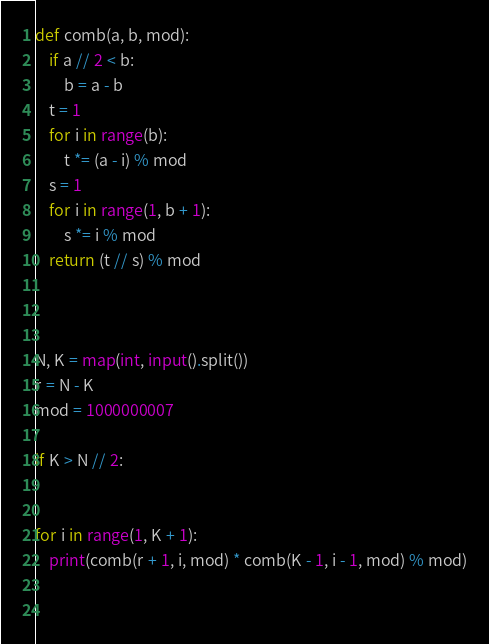Convert code to text. <code><loc_0><loc_0><loc_500><loc_500><_Python_>def comb(a, b, mod):
    if a // 2 < b:
        b = a - b
    t = 1
    for i in range(b):
        t *= (a - i) % mod
    s = 1
    for i in range(1, b + 1):
        s *= i % mod
    return (t // s) % mod



N, K = map(int, input().split())
r = N - K
mod = 1000000007

if K > N // 2:
    

for i in range(1, K + 1):
    print(comb(r + 1, i, mod) * comb(K - 1, i - 1, mod) % mod)
    
    


</code> 